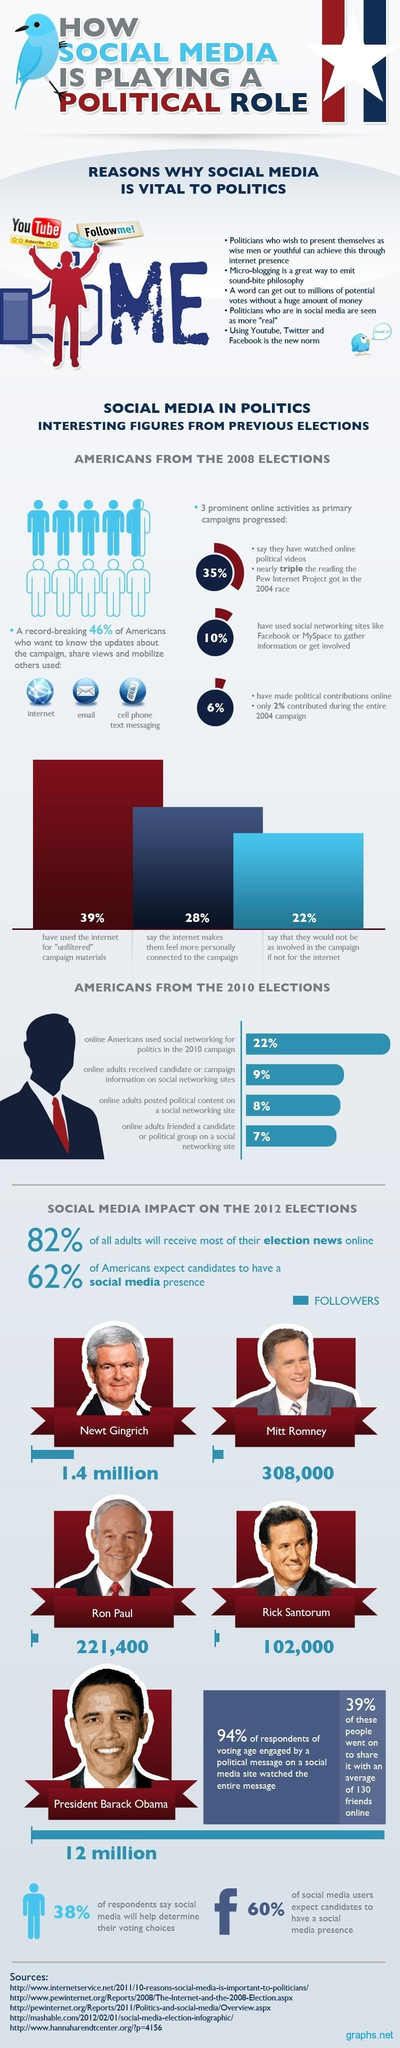What percent of the online adults posted political content on a social networking site during the 2010 US elections?
Answer the question with a short phrase. 8% What percent of the social media users do not expect the candidates to have a social media presence during 2012 US elections? 40% Who has the highest number of social media followers during the 2012 US presidential campaign? President Barack Obama What percent of Americans haven't used social networking sites to gather information or get involved in the 2008 US elections? 90% What is the number of social media followers of Ron Paul during the 2012 US elections? 221,400 How many social media followers were there for Mitt Romney during 2012 US elections? 308,000 What percent of the Americans say that the internet makes them feel more personally connected to the campaign in 2008 elections? 28% 